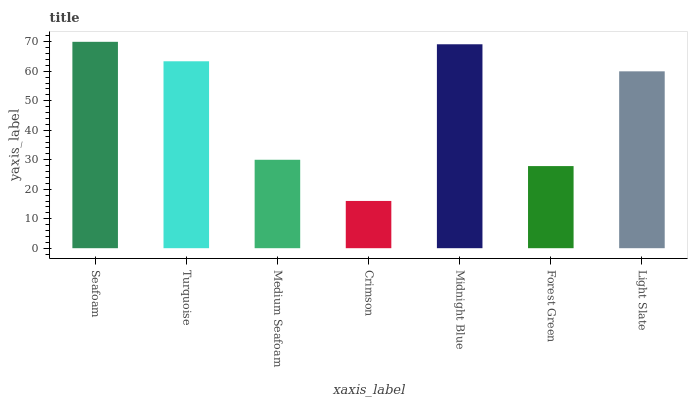Is Crimson the minimum?
Answer yes or no. Yes. Is Seafoam the maximum?
Answer yes or no. Yes. Is Turquoise the minimum?
Answer yes or no. No. Is Turquoise the maximum?
Answer yes or no. No. Is Seafoam greater than Turquoise?
Answer yes or no. Yes. Is Turquoise less than Seafoam?
Answer yes or no. Yes. Is Turquoise greater than Seafoam?
Answer yes or no. No. Is Seafoam less than Turquoise?
Answer yes or no. No. Is Light Slate the high median?
Answer yes or no. Yes. Is Light Slate the low median?
Answer yes or no. Yes. Is Crimson the high median?
Answer yes or no. No. Is Turquoise the low median?
Answer yes or no. No. 